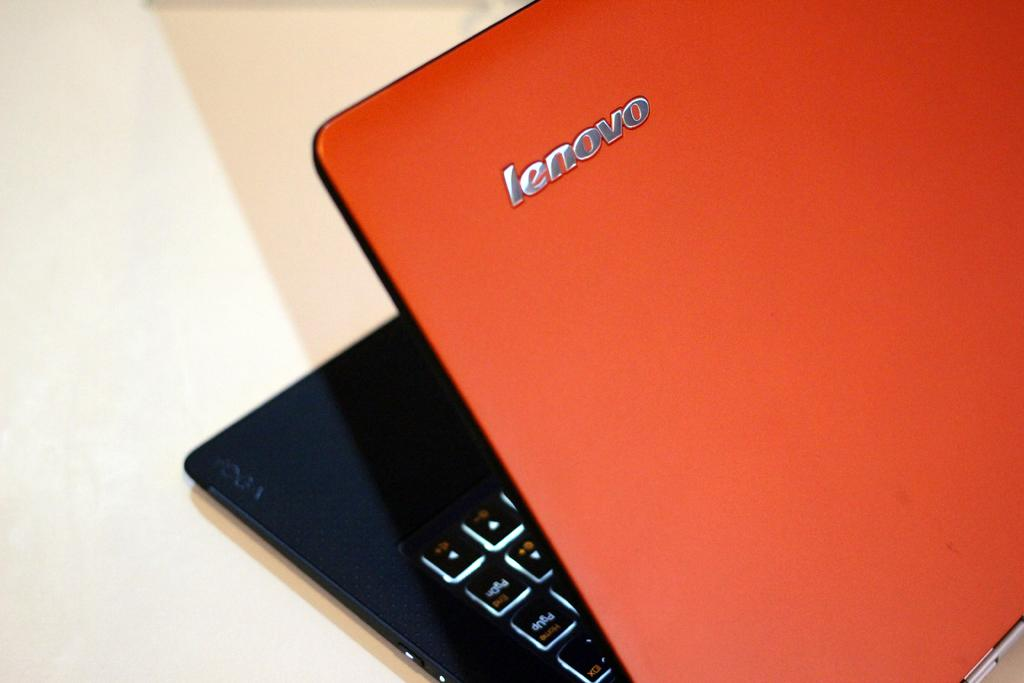What electronic device is visible in the image? There is a laptop in the image. What colors are used for the laptop? The laptop is red and black in color. What type of furniture is present in the image? There is a table in the image. What type of fruit is being used to power the laptop in the image? There is no fruit present in the image, and the laptop is not powered by fruit. 